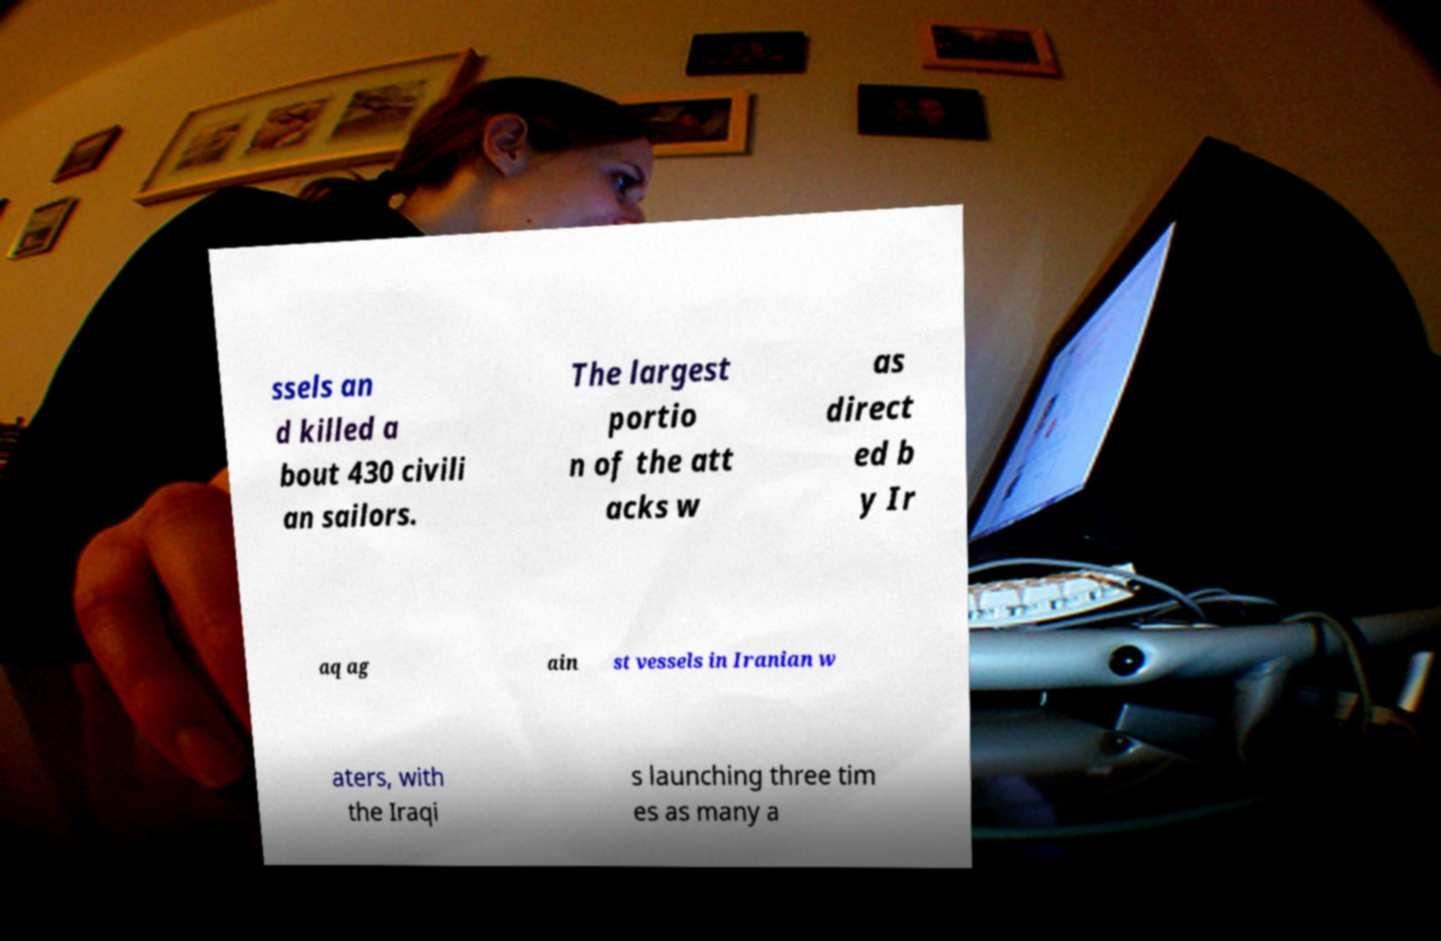Please identify and transcribe the text found in this image. ssels an d killed a bout 430 civili an sailors. The largest portio n of the att acks w as direct ed b y Ir aq ag ain st vessels in Iranian w aters, with the Iraqi s launching three tim es as many a 